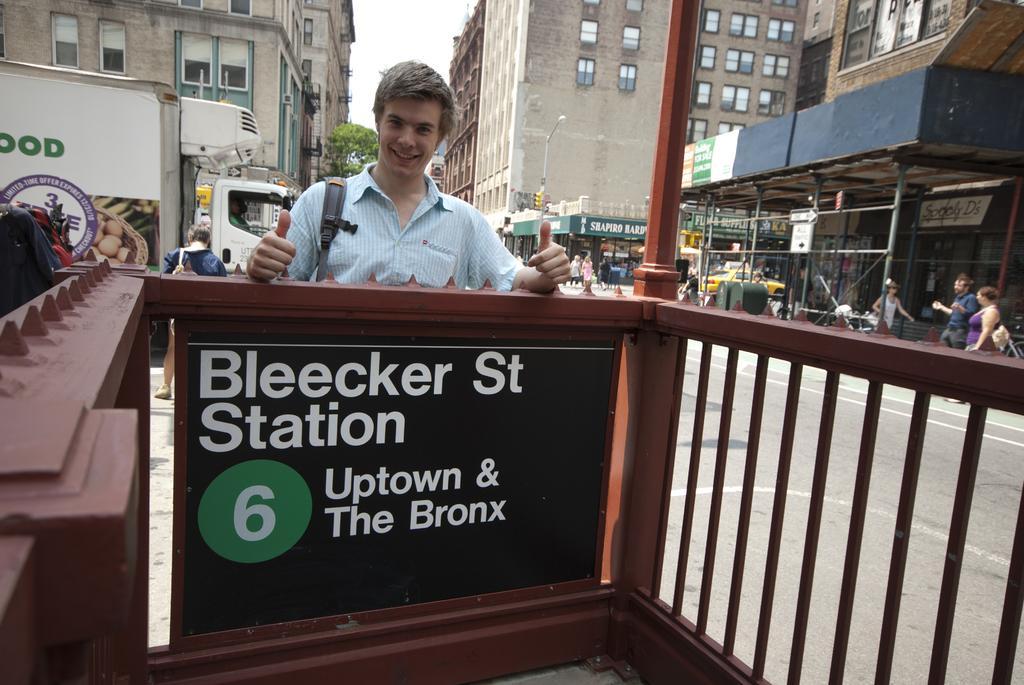Describe this image in one or two sentences. This picture is clicked outside the city. In front of the picture, we see a black color board with some text written on it. Beside that, there is a railing. Behind the board, we see a man in blue shirt is standing. He is smiling. Behind him, we see a vehicle in white color is moving on the road. On the right side, we see people walking on the sideways. We see buildings and street lights on the right side. In the left top of the picture, we see buildings and trees. 